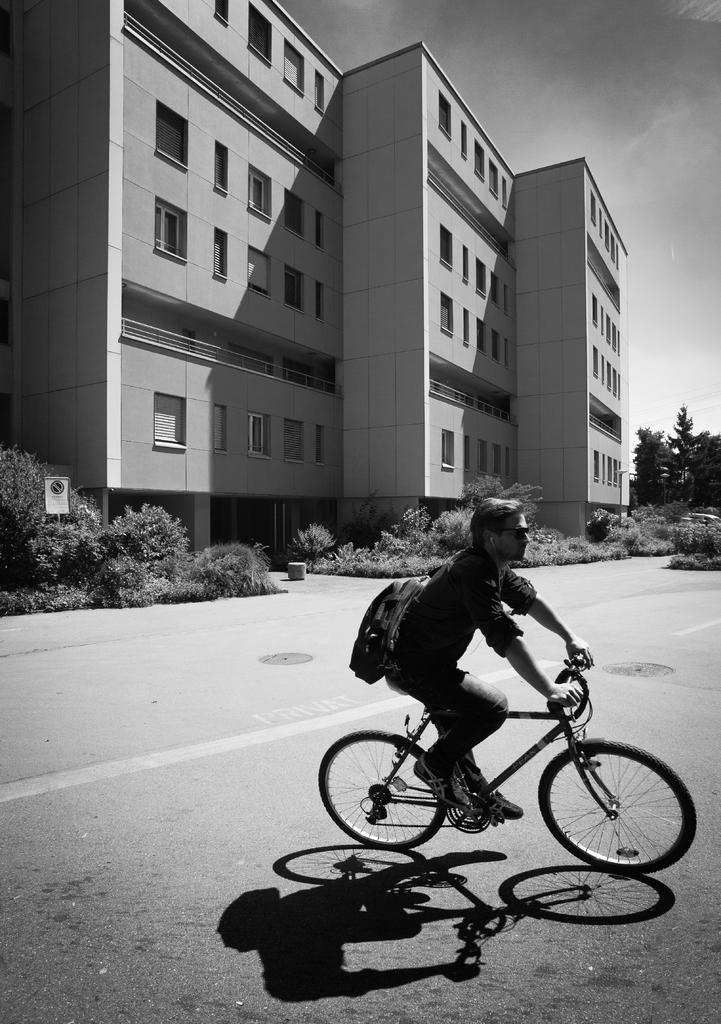What is the main subject of the image? The main subject of the image is a man. What is the man doing in the image? The man is riding a cycle on the road. What is attached to the back of the cycle? The man has a bag behind him. What can be seen in the background of the image? There is a building in the background of the image. What type of vegetation is present near the building? There are plants at the bottom of the building. What verse is the man reciting while riding the cycle in the image? There is no indication in the image that the man is reciting a verse, so it cannot be determined from the picture. 